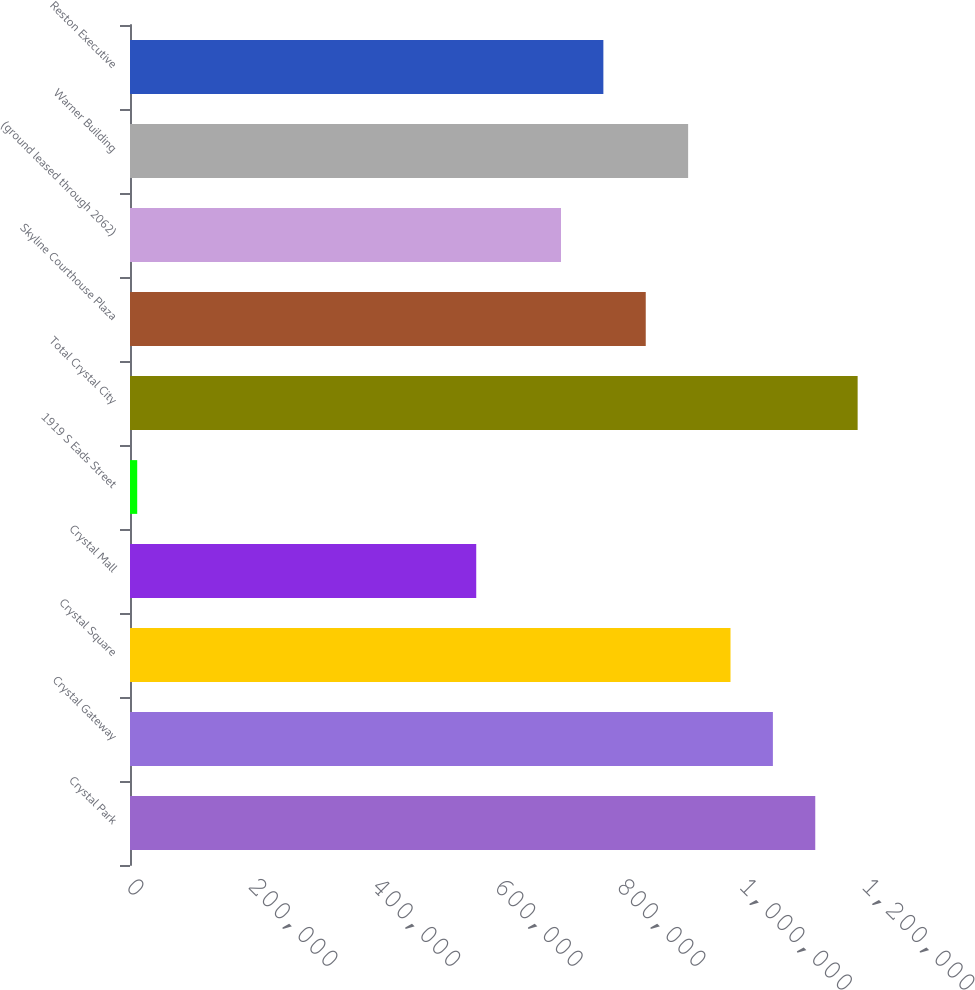Convert chart to OTSL. <chart><loc_0><loc_0><loc_500><loc_500><bar_chart><fcel>Crystal Park<fcel>Crystal Gateway<fcel>Crystal Square<fcel>Crystal Mall<fcel>1919 S Eads Street<fcel>Total Crystal City<fcel>Skyline Courthouse Plaza<fcel>(ground leased through 2062)<fcel>Warner Building<fcel>Reston Executive<nl><fcel>1.11727e+06<fcel>1.04818e+06<fcel>979084<fcel>564515<fcel>11757<fcel>1.18637e+06<fcel>840895<fcel>702705<fcel>909989<fcel>771800<nl></chart> 